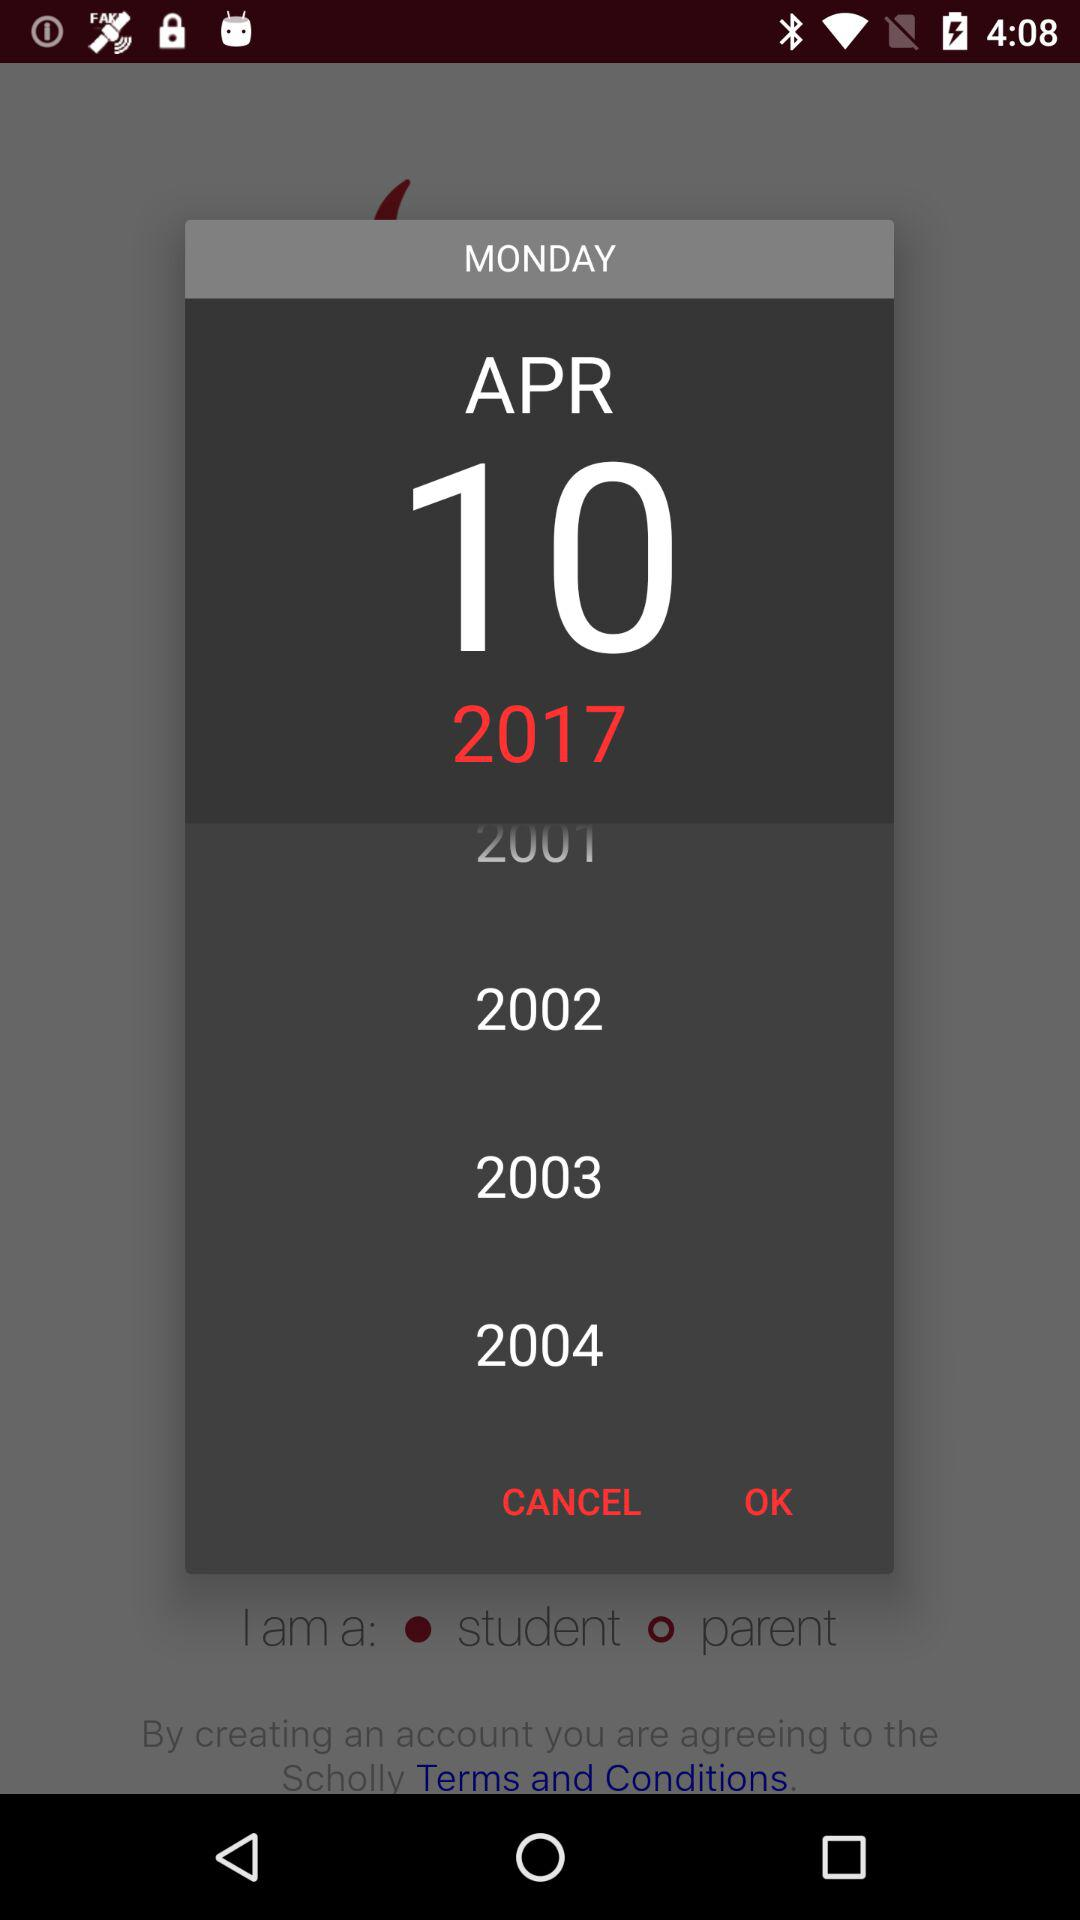Which gender did the user select?
When the provided information is insufficient, respond with <no answer>. <no answer> 